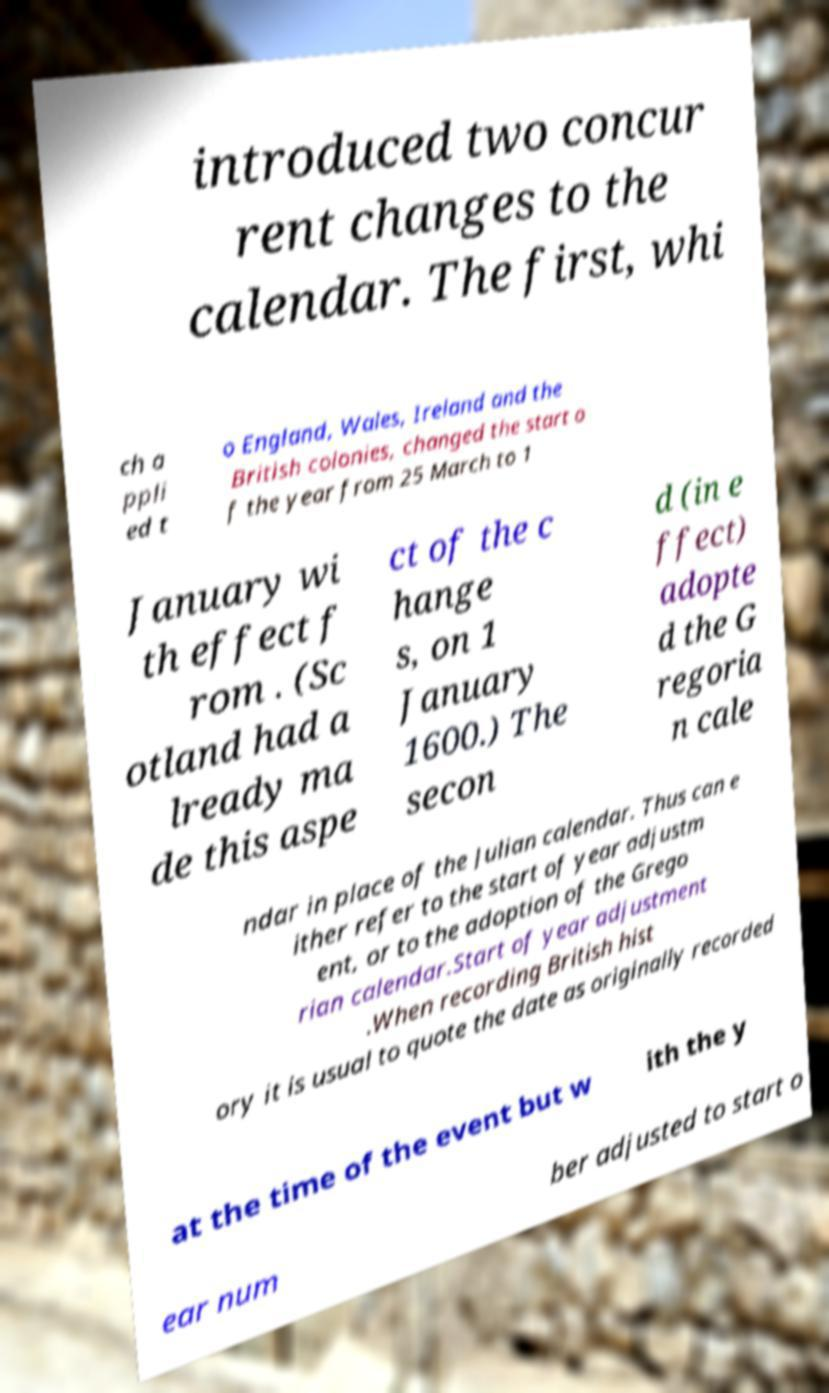Can you accurately transcribe the text from the provided image for me? introduced two concur rent changes to the calendar. The first, whi ch a ppli ed t o England, Wales, Ireland and the British colonies, changed the start o f the year from 25 March to 1 January wi th effect f rom . (Sc otland had a lready ma de this aspe ct of the c hange s, on 1 January 1600.) The secon d (in e ffect) adopte d the G regoria n cale ndar in place of the Julian calendar. Thus can e ither refer to the start of year adjustm ent, or to the adoption of the Grego rian calendar.Start of year adjustment .When recording British hist ory it is usual to quote the date as originally recorded at the time of the event but w ith the y ear num ber adjusted to start o 